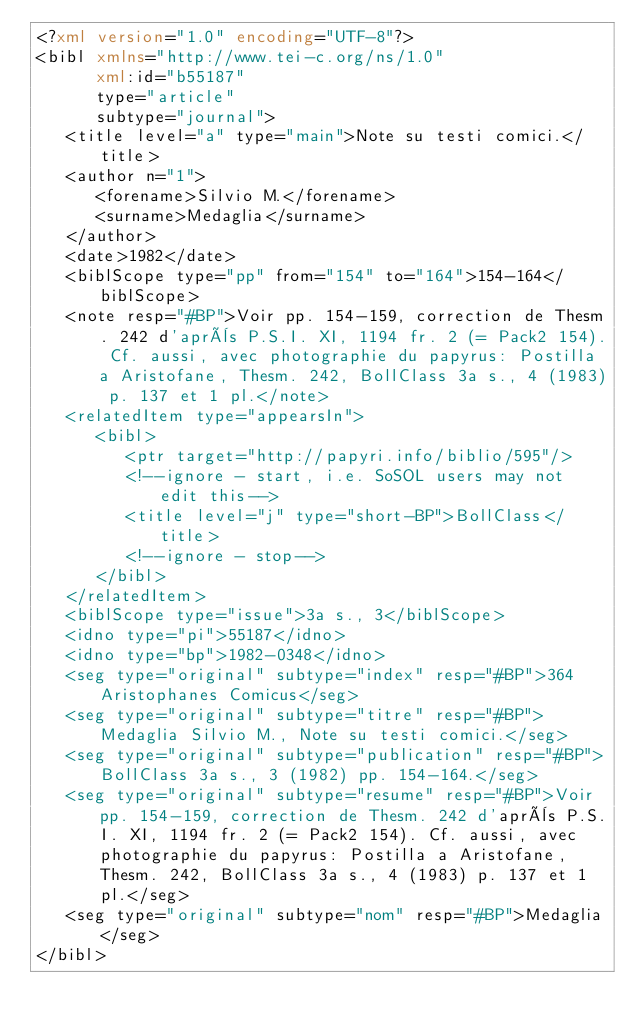Convert code to text. <code><loc_0><loc_0><loc_500><loc_500><_XML_><?xml version="1.0" encoding="UTF-8"?>
<bibl xmlns="http://www.tei-c.org/ns/1.0"
      xml:id="b55187"
      type="article"
      subtype="journal">
   <title level="a" type="main">Note su testi comici.</title>
   <author n="1">
      <forename>Silvio M.</forename>
      <surname>Medaglia</surname>
   </author>
   <date>1982</date>
   <biblScope type="pp" from="154" to="164">154-164</biblScope>
   <note resp="#BP">Voir pp. 154-159, correction de Thesm. 242 d'après P.S.I. XI, 1194 fr. 2 (= Pack2 154). Cf. aussi, avec photographie du papyrus: Postilla a Aristofane, Thesm. 242, BollClass 3a s., 4 (1983) p. 137 et 1 pl.</note>
   <relatedItem type="appearsIn">
      <bibl>
         <ptr target="http://papyri.info/biblio/595"/>
         <!--ignore - start, i.e. SoSOL users may not edit this-->
         <title level="j" type="short-BP">BollClass</title>
         <!--ignore - stop-->
      </bibl>
   </relatedItem>
   <biblScope type="issue">3a s., 3</biblScope>
   <idno type="pi">55187</idno>
   <idno type="bp">1982-0348</idno>
   <seg type="original" subtype="index" resp="#BP">364 Aristophanes Comicus</seg>
   <seg type="original" subtype="titre" resp="#BP">Medaglia Silvio M., Note su testi comici.</seg>
   <seg type="original" subtype="publication" resp="#BP">BollClass 3a s., 3 (1982) pp. 154-164.</seg>
   <seg type="original" subtype="resume" resp="#BP">Voir pp. 154-159, correction de Thesm. 242 d'après P.S.I. XI, 1194 fr. 2 (= Pack2 154). Cf. aussi, avec photographie du papyrus: Postilla a Aristofane, Thesm. 242, BollClass 3a s., 4 (1983) p. 137 et 1 pl.</seg>
   <seg type="original" subtype="nom" resp="#BP">Medaglia</seg>
</bibl>
</code> 